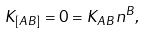<formula> <loc_0><loc_0><loc_500><loc_500>K _ { [ A B ] } = 0 = K _ { A B } n ^ { B } ,</formula> 